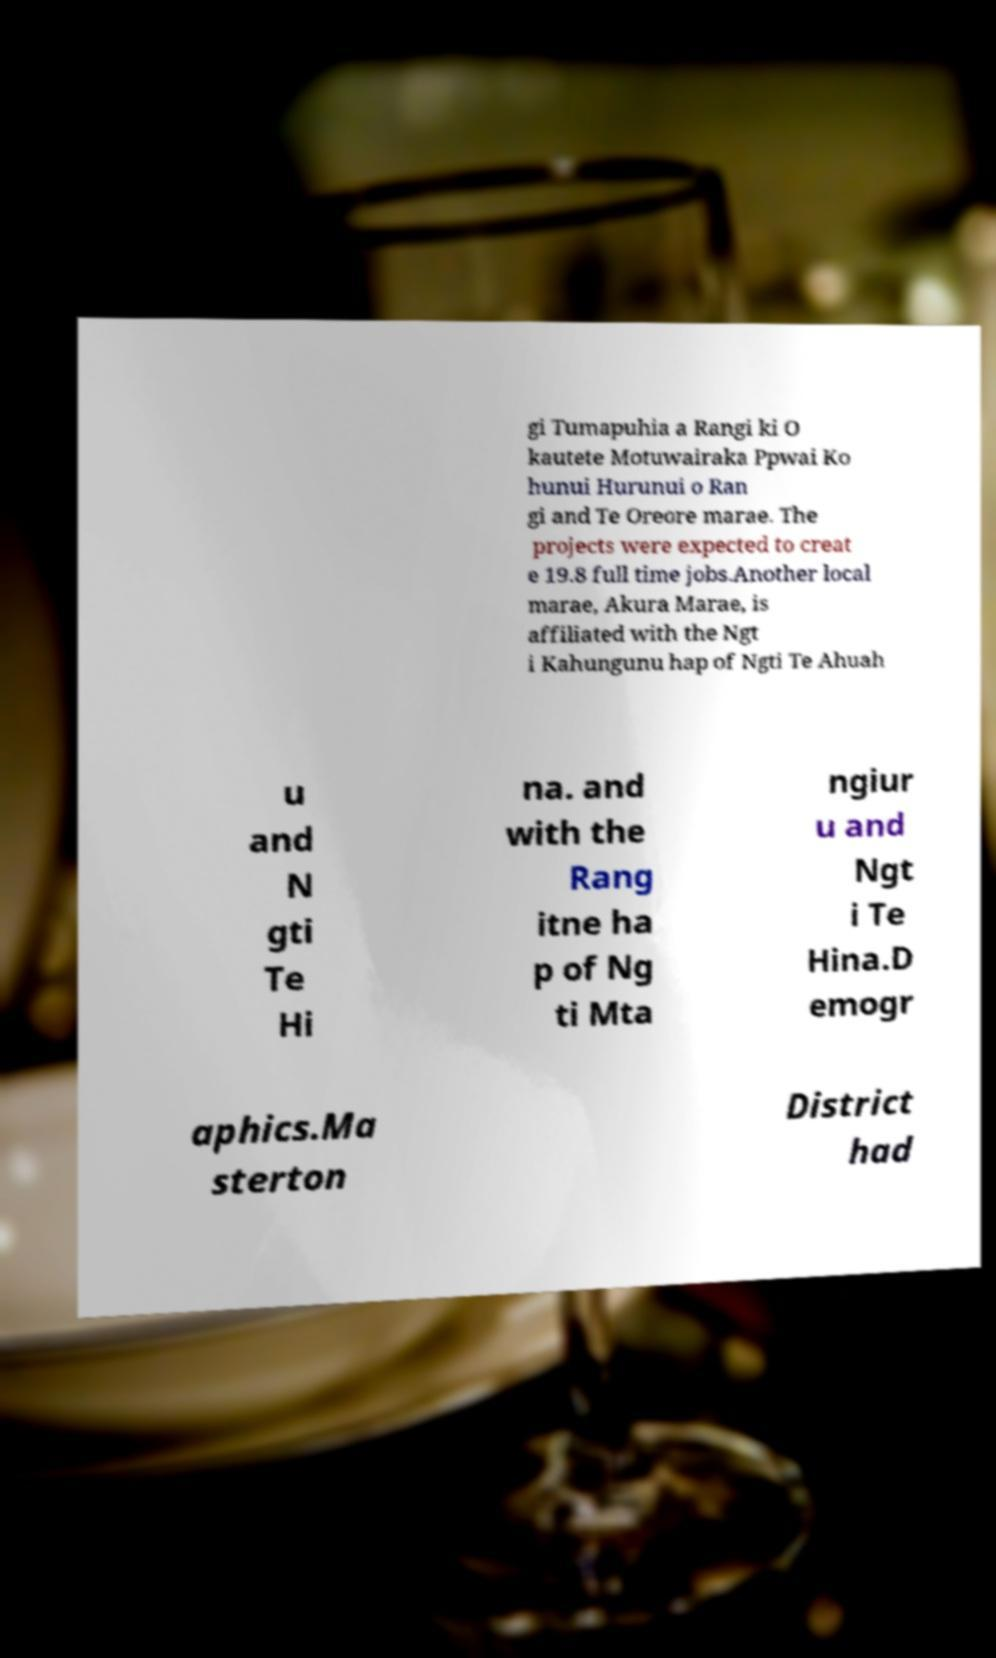There's text embedded in this image that I need extracted. Can you transcribe it verbatim? gi Tumapuhia a Rangi ki O kautete Motuwairaka Ppwai Ko hunui Hurunui o Ran gi and Te Oreore marae. The projects were expected to creat e 19.8 full time jobs.Another local marae, Akura Marae, is affiliated with the Ngt i Kahungunu hap of Ngti Te Ahuah u and N gti Te Hi na. and with the Rang itne ha p of Ng ti Mta ngiur u and Ngt i Te Hina.D emogr aphics.Ma sterton District had 